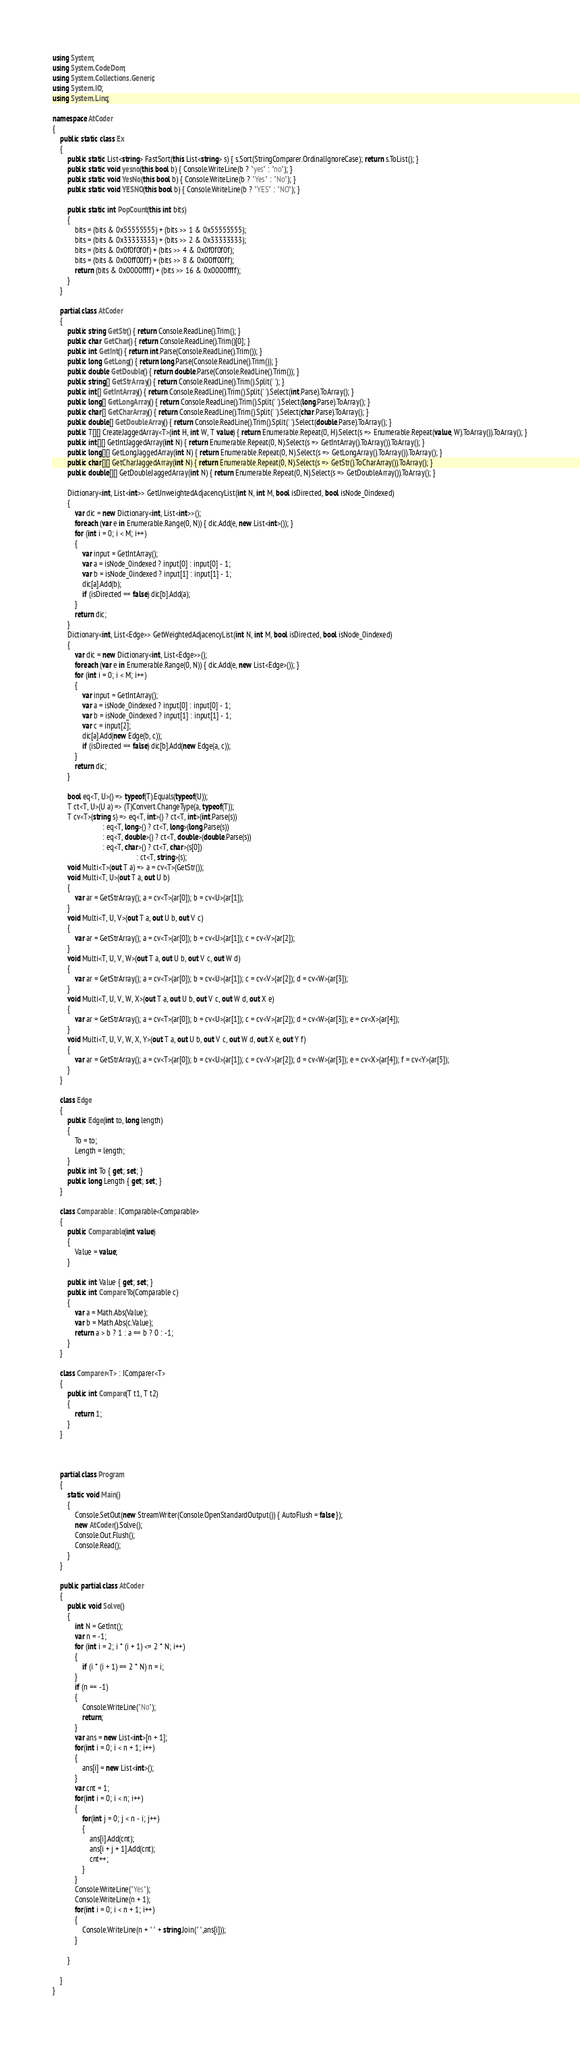<code> <loc_0><loc_0><loc_500><loc_500><_C#_>using System;
using System.CodeDom;
using System.Collections.Generic;
using System.IO;
using System.Linq;

namespace AtCoder
{
    public static class Ex
    {
        public static List<string> FastSort(this List<string> s) { s.Sort(StringComparer.OrdinalIgnoreCase); return s.ToList(); }
        public static void yesno(this bool b) { Console.WriteLine(b ? "yes" : "no"); }
        public static void YesNo(this bool b) { Console.WriteLine(b ? "Yes" : "No"); }
        public static void YESNO(this bool b) { Console.WriteLine(b ? "YES" : "NO"); }

        public static int PopCount(this int bits)
        {
            bits = (bits & 0x55555555) + (bits >> 1 & 0x55555555);
            bits = (bits & 0x33333333) + (bits >> 2 & 0x33333333);
            bits = (bits & 0x0f0f0f0f) + (bits >> 4 & 0x0f0f0f0f);
            bits = (bits & 0x00ff00ff) + (bits >> 8 & 0x00ff00ff);
            return (bits & 0x0000ffff) + (bits >> 16 & 0x0000ffff);
        }
    }

    partial class AtCoder
    {
        public string GetStr() { return Console.ReadLine().Trim(); }
        public char GetChar() { return Console.ReadLine().Trim()[0]; }
        public int GetInt() { return int.Parse(Console.ReadLine().Trim()); }
        public long GetLong() { return long.Parse(Console.ReadLine().Trim()); }
        public double GetDouble() { return double.Parse(Console.ReadLine().Trim()); }
        public string[] GetStrArray() { return Console.ReadLine().Trim().Split(' '); }
        public int[] GetIntArray() { return Console.ReadLine().Trim().Split(' ').Select(int.Parse).ToArray(); }
        public long[] GetLongArray() { return Console.ReadLine().Trim().Split(' ').Select(long.Parse).ToArray(); }
        public char[] GetCharArray() { return Console.ReadLine().Trim().Split(' ').Select(char.Parse).ToArray(); }
        public double[] GetDoubleArray() { return Console.ReadLine().Trim().Split(' ').Select(double.Parse).ToArray(); }
        public T[][] CreateJaggedArray<T>(int H, int W, T value) { return Enumerable.Repeat(0, H).Select(s => Enumerable.Repeat(value, W).ToArray()).ToArray(); }
        public int[][] GetIntJaggedArray(int N) { return Enumerable.Repeat(0, N).Select(s => GetIntArray().ToArray()).ToArray(); }
        public long[][] GetLongJaggedArray(int N) { return Enumerable.Repeat(0, N).Select(s => GetLongArray().ToArray()).ToArray(); }
        public char[][] GetCharJaggedArray(int N) { return Enumerable.Repeat(0, N).Select(s => GetStr().ToCharArray()).ToArray(); }
        public double[][] GetDoubleJaggedArray(int N) { return Enumerable.Repeat(0, N).Select(s => GetDoubleArray()).ToArray(); }

        Dictionary<int, List<int>> GetUnweightedAdjacencyList(int N, int M, bool isDirected, bool isNode_0indexed)
        {
            var dic = new Dictionary<int, List<int>>();
            foreach (var e in Enumerable.Range(0, N)) { dic.Add(e, new List<int>()); }
            for (int i = 0; i < M; i++)
            {
                var input = GetIntArray();
                var a = isNode_0indexed ? input[0] : input[0] - 1;
                var b = isNode_0indexed ? input[1] : input[1] - 1;
                dic[a].Add(b);
                if (isDirected == false) dic[b].Add(a);
            }
            return dic;
        }
        Dictionary<int, List<Edge>> GetWeightedAdjacencyList(int N, int M, bool isDirected, bool isNode_0indexed)
        {
            var dic = new Dictionary<int, List<Edge>>();
            foreach (var e in Enumerable.Range(0, N)) { dic.Add(e, new List<Edge>()); }
            for (int i = 0; i < M; i++)
            {
                var input = GetIntArray();
                var a = isNode_0indexed ? input[0] : input[0] - 1;
                var b = isNode_0indexed ? input[1] : input[1] - 1;
                var c = input[2];
                dic[a].Add(new Edge(b, c));
                if (isDirected == false) dic[b].Add(new Edge(a, c));
            }
            return dic;
        }

        bool eq<T, U>() => typeof(T).Equals(typeof(U));
        T ct<T, U>(U a) => (T)Convert.ChangeType(a, typeof(T));
        T cv<T>(string s) => eq<T, int>() ? ct<T, int>(int.Parse(s))
                           : eq<T, long>() ? ct<T, long>(long.Parse(s))
                           : eq<T, double>() ? ct<T, double>(double.Parse(s))
                           : eq<T, char>() ? ct<T, char>(s[0])
                                             : ct<T, string>(s);
        void Multi<T>(out T a) => a = cv<T>(GetStr());
        void Multi<T, U>(out T a, out U b)
        {
            var ar = GetStrArray(); a = cv<T>(ar[0]); b = cv<U>(ar[1]);
        }
        void Multi<T, U, V>(out T a, out U b, out V c)
        {
            var ar = GetStrArray(); a = cv<T>(ar[0]); b = cv<U>(ar[1]); c = cv<V>(ar[2]);
        }
        void Multi<T, U, V, W>(out T a, out U b, out V c, out W d)
        {
            var ar = GetStrArray(); a = cv<T>(ar[0]); b = cv<U>(ar[1]); c = cv<V>(ar[2]); d = cv<W>(ar[3]);
        }
        void Multi<T, U, V, W, X>(out T a, out U b, out V c, out W d, out X e)
        {
            var ar = GetStrArray(); a = cv<T>(ar[0]); b = cv<U>(ar[1]); c = cv<V>(ar[2]); d = cv<W>(ar[3]); e = cv<X>(ar[4]);
        }
        void Multi<T, U, V, W, X, Y>(out T a, out U b, out V c, out W d, out X e, out Y f)
        {
            var ar = GetStrArray(); a = cv<T>(ar[0]); b = cv<U>(ar[1]); c = cv<V>(ar[2]); d = cv<W>(ar[3]); e = cv<X>(ar[4]); f = cv<Y>(ar[5]);
        }
    }

    class Edge
    {
        public Edge(int to, long length)
        {
            To = to;
            Length = length;
        }
        public int To { get; set; }
        public long Length { get; set; }
    }

    class Comparable : IComparable<Comparable>
    {
        public Comparable(int value)
        {
            Value = value;
        }

        public int Value { get; set; }
        public int CompareTo(Comparable c)
        {
            var a = Math.Abs(Value);
            var b = Math.Abs(c.Value);
            return a > b ? 1 : a == b ? 0 : -1;
        }
    }

    class Comparer<T> : IComparer<T>
    {
        public int Compare(T t1, T t2)
        {
            return 1;
        }
    }



    partial class Program
    {
        static void Main()
        {
            Console.SetOut(new StreamWriter(Console.OpenStandardOutput()) { AutoFlush = false });
            new AtCoder().Solve();
            Console.Out.Flush();
            Console.Read();
        }
    }

    public partial class AtCoder
    {
        public void Solve()
        {
            int N = GetInt();
            var n = -1;
            for (int i = 2; i * (i + 1) <= 2 * N; i++)
            {
                if (i * (i + 1) == 2 * N) n = i;
            }
            if (n == -1)
            {
                Console.WriteLine("No");
                return;
            }
            var ans = new List<int>[n + 1];
            for(int i = 0; i < n + 1; i++)
            {
                ans[i] = new List<int>();
            }
            var cnt = 1;
            for(int i = 0; i < n; i++)
            {
                for(int j = 0; j < n - i; j++)
                {
                    ans[i].Add(cnt);
                    ans[i + j + 1].Add(cnt);
                    cnt++;
                }
            }
            Console.WriteLine("Yes");
            Console.WriteLine(n + 1);
            for(int i = 0; i < n + 1; i++)
            {
                Console.WriteLine(n + " " + string.Join(" ",ans[i]));
            }

        }

    }
}
</code> 